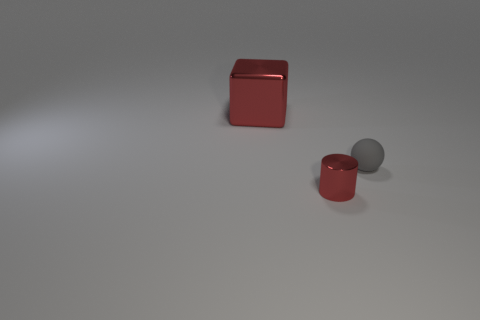What size is the block that is the same material as the cylinder?
Offer a terse response. Large. What is the shape of the metal object in front of the thing that is to the left of the red cylinder?
Provide a short and direct response. Cylinder. There is a thing that is behind the small red shiny cylinder and to the right of the cube; what size is it?
Offer a very short reply. Small. Are there any big red things of the same shape as the tiny gray object?
Keep it short and to the point. No. Is there anything else that has the same shape as the large red thing?
Your answer should be compact. No. What is the red object right of the red shiny thing behind the object that is in front of the tiny gray rubber ball made of?
Ensure brevity in your answer.  Metal. Are there any red metallic cylinders that have the same size as the rubber object?
Ensure brevity in your answer.  Yes. There is a thing to the right of the small thing in front of the small sphere; what color is it?
Make the answer very short. Gray. How many shiny blocks are there?
Ensure brevity in your answer.  1. Is the color of the metal block the same as the rubber ball?
Keep it short and to the point. No. 